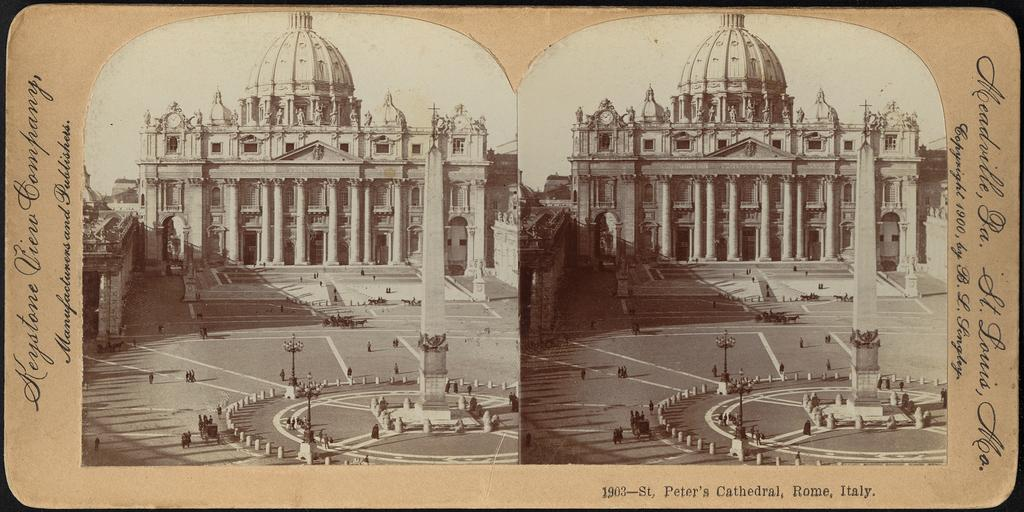<image>
Relay a brief, clear account of the picture shown. Two old photographs of St Peter's Cathedral, Rome, Italy. 